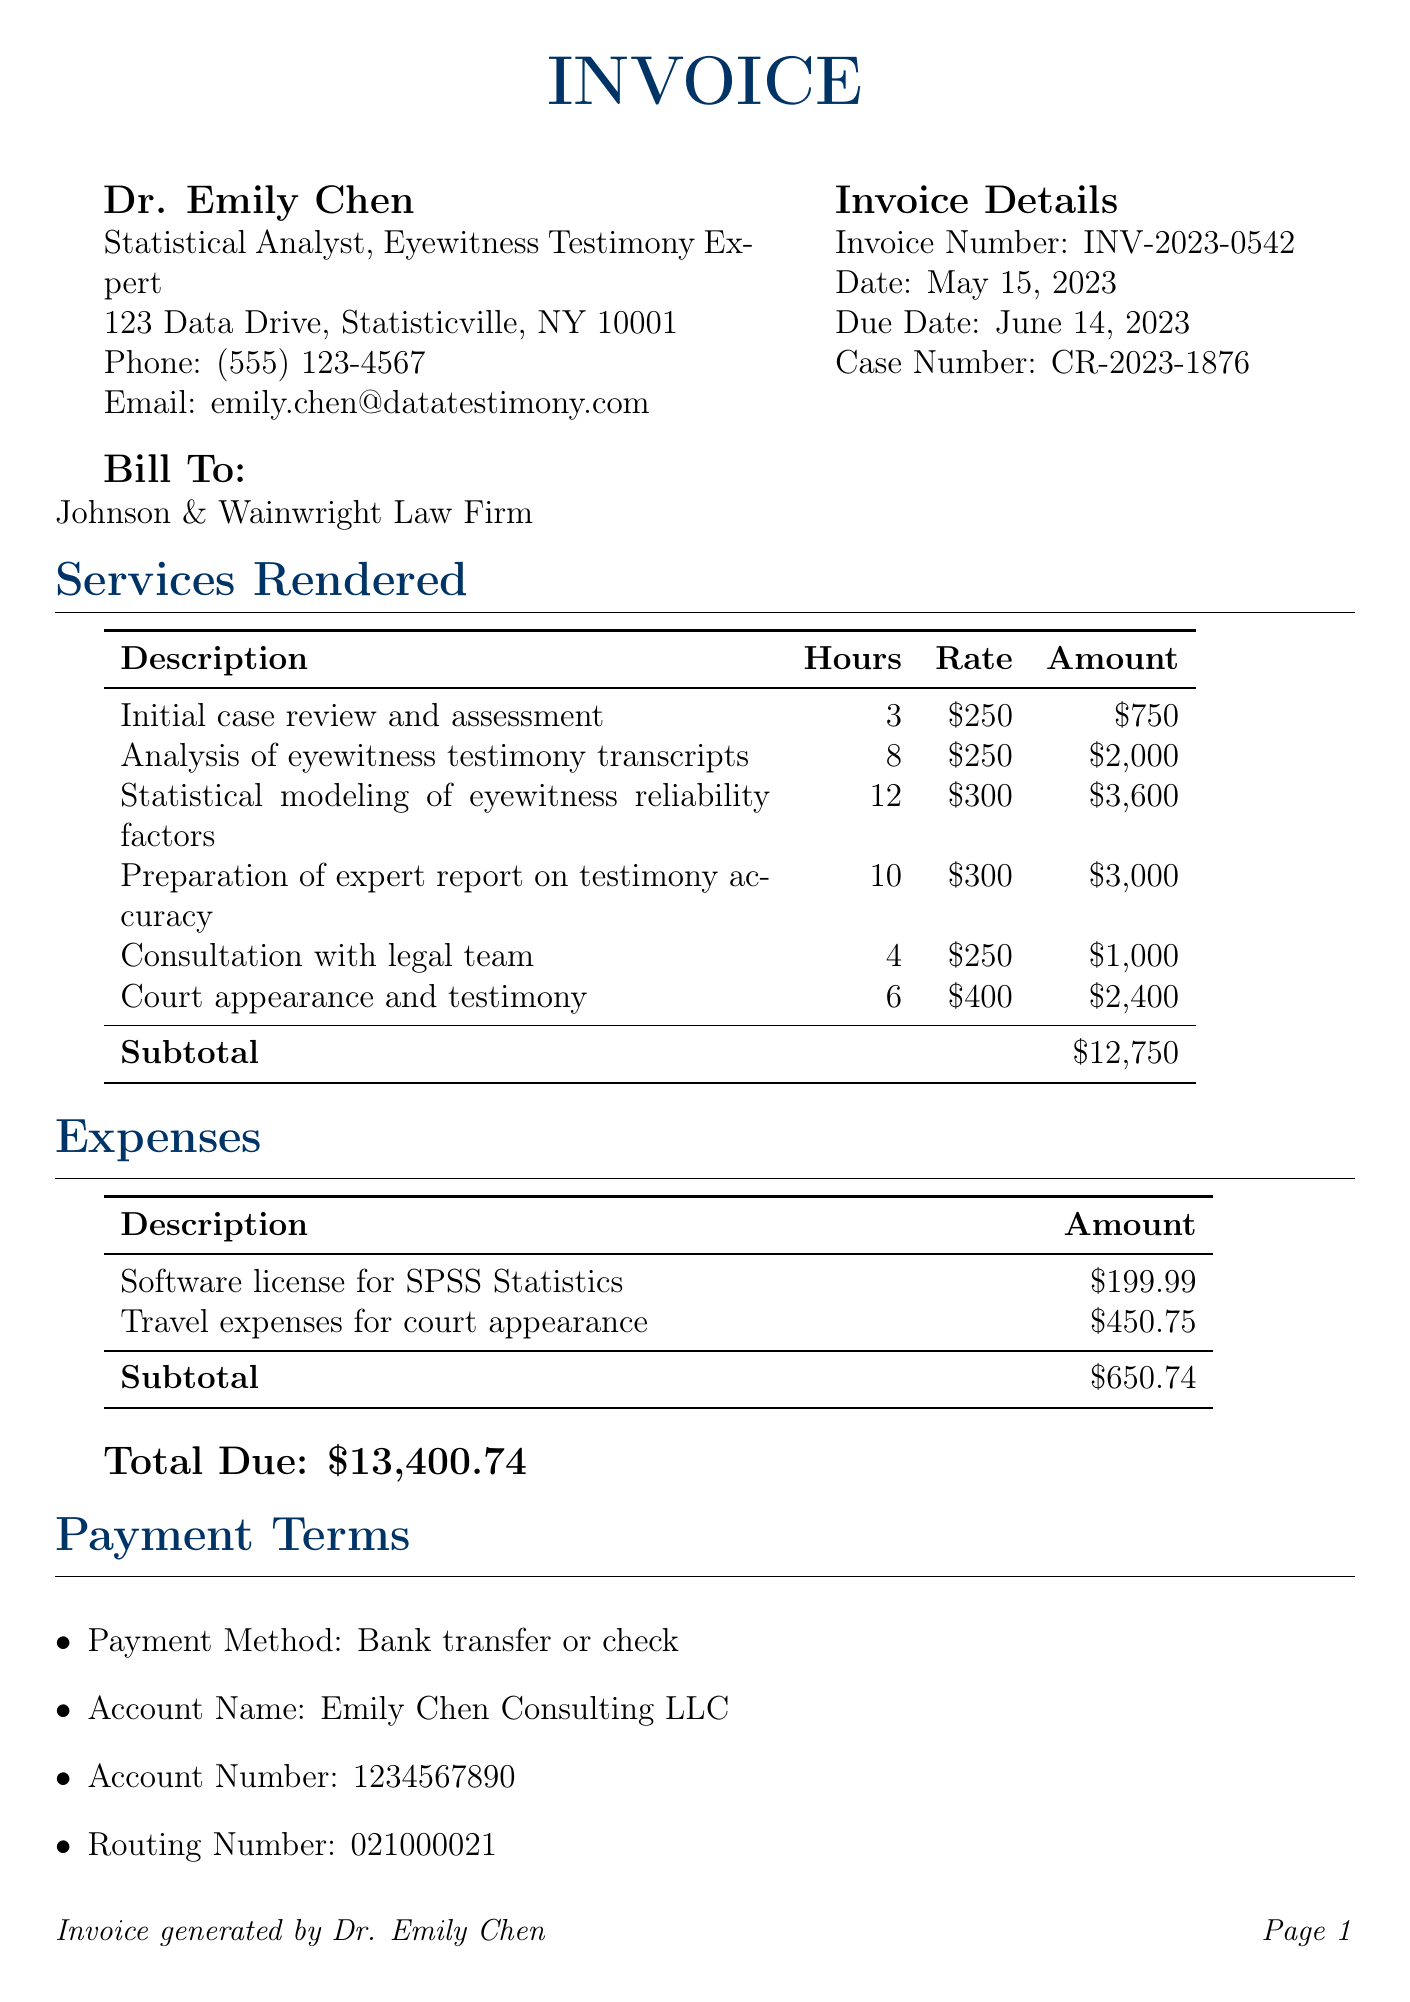what is the invoice number? The invoice number is listed in the document under invoice details, which states "Invoice Number: INV-2023-0542."
Answer: INV-2023-0542 who is the consultant? The document provides the consultant's name, which is indicated as "Dr. Emily Chen."
Answer: Dr. Emily Chen how many hours were spent on the analysis of eyewitness testimony transcripts? The hours for this activity are specified in the services section, showing "Analysis of eyewitness testimony transcripts" took 8 hours.
Answer: 8 what is the total due amount? The total due is calculated as the sum of services and expenses, clearly mentioned in the document as "Total Due: $13,400.74."
Answer: $13,400.74 what was the hourly rate for court appearance and testimony? The document specifies the rate for this service, listed under services as "$400."
Answer: $400 how many services were listed in the invoice? The document includes a table for services rendered, which totals six distinct entries.
Answer: 6 what is the payment method mentioned in the payment terms? The payment method is specified as "Bank transfer or check" in the payment terms section.
Answer: Bank transfer or check what are the expenses listed in the document? The document details two expenses: "Software license for SPSS Statistics" and "Travel expenses for court appearance."
Answer: Software license for SPSS Statistics, Travel expenses for court appearance when is the due date for payment? The due date is explicitly stated in the invoice details section, which shows "Due Date: June 14, 2023."
Answer: June 14, 2023 